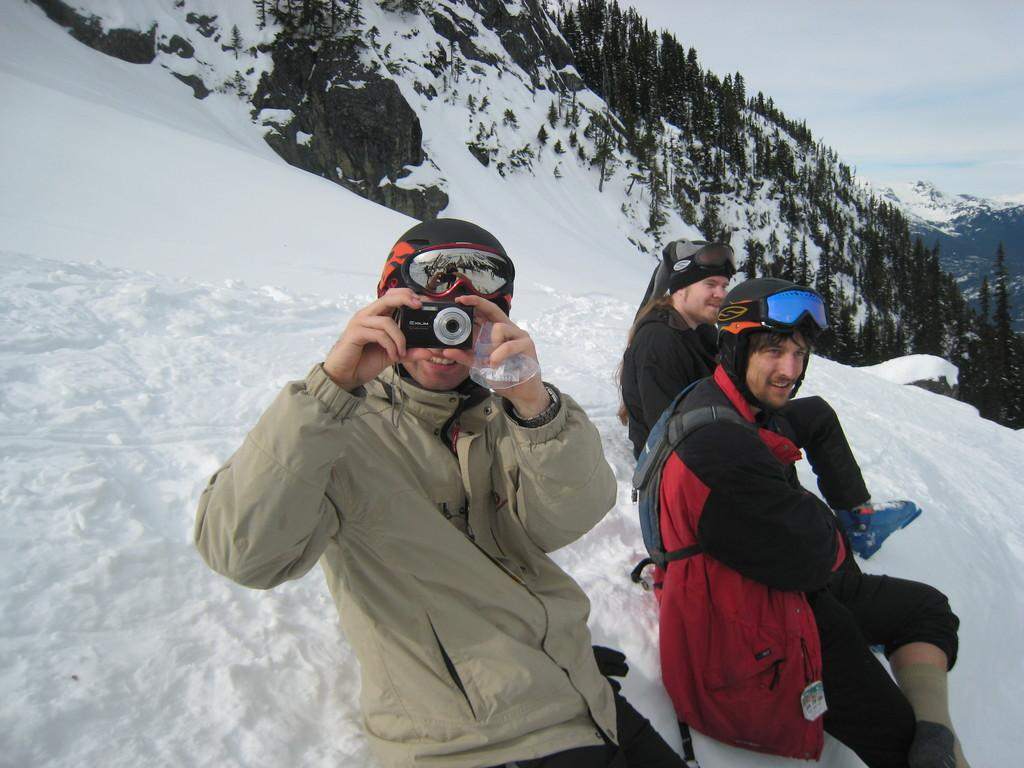What is the surface that the persons are sitting on in the image? The persons are sitting on snow in the image. What is the condition of the mountain in the image? The mountain is filled with snow. Are there any natural elements visible in the image? Yes, there are trees in the image. What is the person wearing a jacket doing? The person wearing a jacket is holding a camera. What is one person carrying in the image? One person is carrying a bag. What type of sweater is the person wearing a jacket smashing on the mountain? There is no sweater present in the image, and no one is smashing anything. 